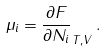<formula> <loc_0><loc_0><loc_500><loc_500>\mu _ { i } = \frac { \partial F } { \partial N _ { i } } _ { T , V } \, .</formula> 